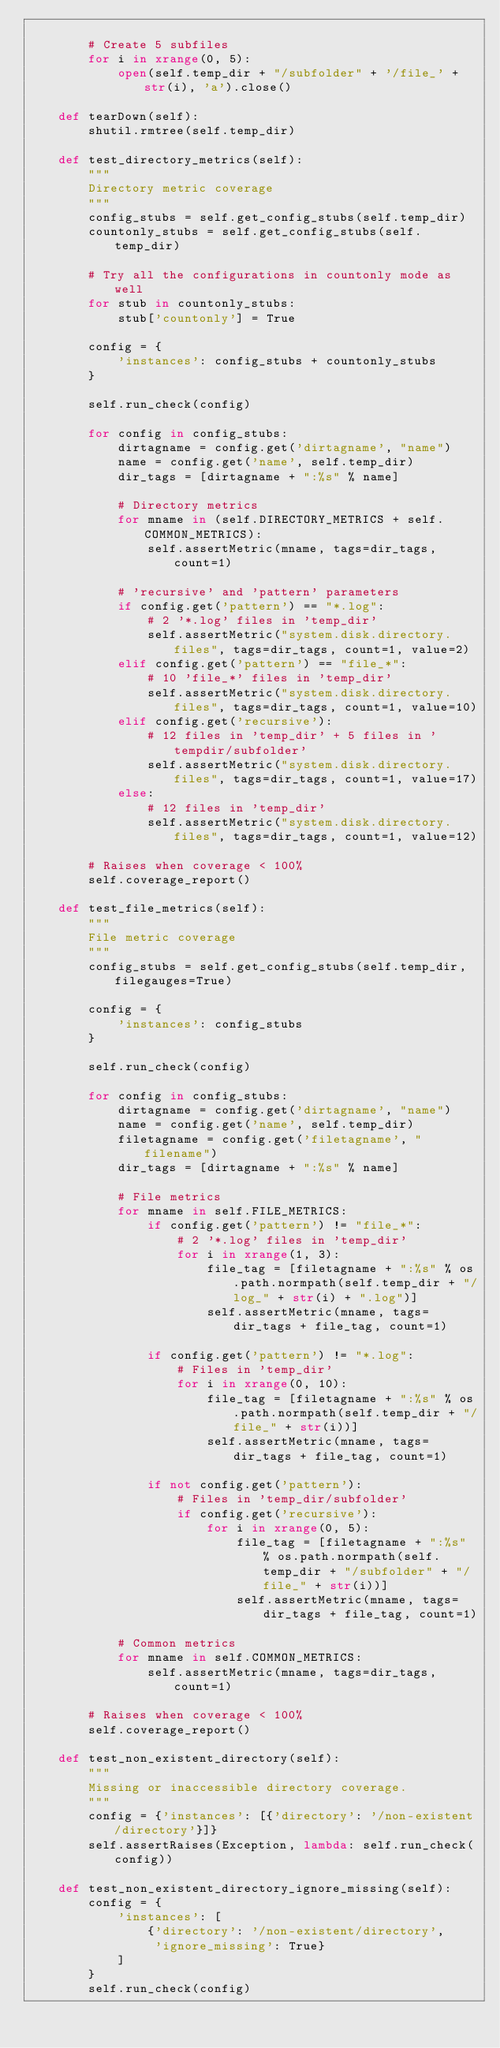<code> <loc_0><loc_0><loc_500><loc_500><_Python_>
        # Create 5 subfiles
        for i in xrange(0, 5):
            open(self.temp_dir + "/subfolder" + '/file_' + str(i), 'a').close()

    def tearDown(self):
        shutil.rmtree(self.temp_dir)

    def test_directory_metrics(self):
        """
        Directory metric coverage
        """
        config_stubs = self.get_config_stubs(self.temp_dir)
        countonly_stubs = self.get_config_stubs(self.temp_dir)

        # Try all the configurations in countonly mode as well
        for stub in countonly_stubs:
            stub['countonly'] = True

        config = {
            'instances': config_stubs + countonly_stubs
        }

        self.run_check(config)

        for config in config_stubs:
            dirtagname = config.get('dirtagname', "name")
            name = config.get('name', self.temp_dir)
            dir_tags = [dirtagname + ":%s" % name]

            # Directory metrics
            for mname in (self.DIRECTORY_METRICS + self.COMMON_METRICS):
                self.assertMetric(mname, tags=dir_tags, count=1)

            # 'recursive' and 'pattern' parameters
            if config.get('pattern') == "*.log":
                # 2 '*.log' files in 'temp_dir'
                self.assertMetric("system.disk.directory.files", tags=dir_tags, count=1, value=2)
            elif config.get('pattern') == "file_*":
                # 10 'file_*' files in 'temp_dir'
                self.assertMetric("system.disk.directory.files", tags=dir_tags, count=1, value=10)
            elif config.get('recursive'):
                # 12 files in 'temp_dir' + 5 files in 'tempdir/subfolder'
                self.assertMetric("system.disk.directory.files", tags=dir_tags, count=1, value=17)
            else:
                # 12 files in 'temp_dir'
                self.assertMetric("system.disk.directory.files", tags=dir_tags, count=1, value=12)

        # Raises when coverage < 100%
        self.coverage_report()

    def test_file_metrics(self):
        """
        File metric coverage
        """
        config_stubs = self.get_config_stubs(self.temp_dir, filegauges=True)

        config = {
            'instances': config_stubs
        }

        self.run_check(config)

        for config in config_stubs:
            dirtagname = config.get('dirtagname', "name")
            name = config.get('name', self.temp_dir)
            filetagname = config.get('filetagname', "filename")
            dir_tags = [dirtagname + ":%s" % name]

            # File metrics
            for mname in self.FILE_METRICS:
                if config.get('pattern') != "file_*":
                    # 2 '*.log' files in 'temp_dir'
                    for i in xrange(1, 3):
                        file_tag = [filetagname + ":%s" % os.path.normpath(self.temp_dir + "/log_" + str(i) + ".log")]
                        self.assertMetric(mname, tags=dir_tags + file_tag, count=1)

                if config.get('pattern') != "*.log":
                    # Files in 'temp_dir'
                    for i in xrange(0, 10):
                        file_tag = [filetagname + ":%s" % os.path.normpath(self.temp_dir + "/file_" + str(i))]
                        self.assertMetric(mname, tags=dir_tags + file_tag, count=1)

                if not config.get('pattern'):
                    # Files in 'temp_dir/subfolder'
                    if config.get('recursive'):
                        for i in xrange(0, 5):
                            file_tag = [filetagname + ":%s" % os.path.normpath(self.temp_dir + "/subfolder" + "/file_" + str(i))]
                            self.assertMetric(mname, tags=dir_tags + file_tag, count=1)

            # Common metrics
            for mname in self.COMMON_METRICS:
                self.assertMetric(mname, tags=dir_tags, count=1)

        # Raises when coverage < 100%
        self.coverage_report()

    def test_non_existent_directory(self):
        """
        Missing or inaccessible directory coverage.
        """
        config = {'instances': [{'directory': '/non-existent/directory'}]}
        self.assertRaises(Exception, lambda: self.run_check(config))

    def test_non_existent_directory_ignore_missing(self):
        config = {
            'instances': [
                {'directory': '/non-existent/directory',
                 'ignore_missing': True}
            ]
        }
        self.run_check(config)
</code> 